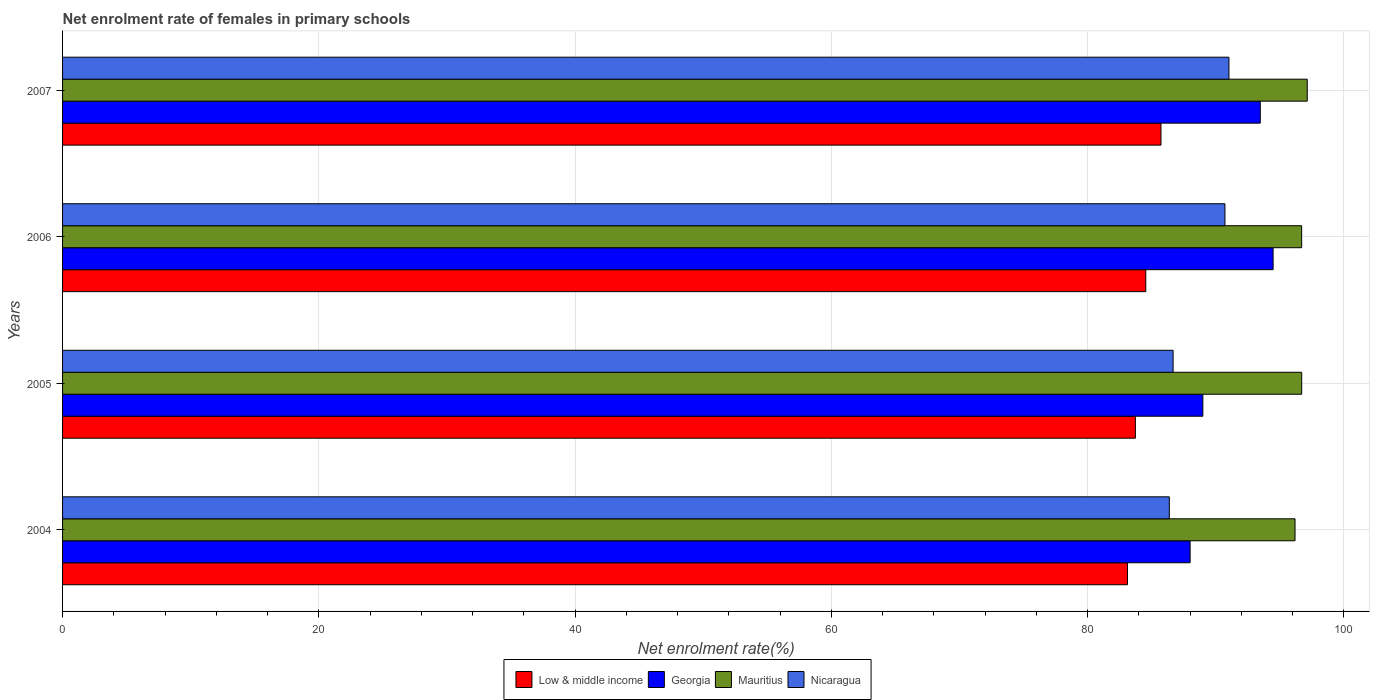Are the number of bars per tick equal to the number of legend labels?
Your answer should be compact. Yes. How many bars are there on the 2nd tick from the bottom?
Provide a short and direct response. 4. What is the label of the 3rd group of bars from the top?
Give a very brief answer. 2005. What is the net enrolment rate of females in primary schools in Georgia in 2005?
Your answer should be very brief. 89. Across all years, what is the maximum net enrolment rate of females in primary schools in Mauritius?
Ensure brevity in your answer.  97.15. Across all years, what is the minimum net enrolment rate of females in primary schools in Low & middle income?
Your answer should be compact. 83.11. In which year was the net enrolment rate of females in primary schools in Low & middle income maximum?
Keep it short and to the point. 2007. In which year was the net enrolment rate of females in primary schools in Nicaragua minimum?
Provide a short and direct response. 2004. What is the total net enrolment rate of females in primary schools in Nicaragua in the graph?
Provide a short and direct response. 354.81. What is the difference between the net enrolment rate of females in primary schools in Mauritius in 2004 and that in 2006?
Your answer should be compact. -0.52. What is the difference between the net enrolment rate of females in primary schools in Georgia in 2004 and the net enrolment rate of females in primary schools in Mauritius in 2006?
Keep it short and to the point. -8.71. What is the average net enrolment rate of females in primary schools in Low & middle income per year?
Give a very brief answer. 84.28. In the year 2007, what is the difference between the net enrolment rate of females in primary schools in Georgia and net enrolment rate of females in primary schools in Nicaragua?
Offer a very short reply. 2.45. What is the ratio of the net enrolment rate of females in primary schools in Georgia in 2006 to that in 2007?
Keep it short and to the point. 1.01. Is the net enrolment rate of females in primary schools in Low & middle income in 2004 less than that in 2005?
Give a very brief answer. Yes. Is the difference between the net enrolment rate of females in primary schools in Georgia in 2006 and 2007 greater than the difference between the net enrolment rate of females in primary schools in Nicaragua in 2006 and 2007?
Your answer should be very brief. Yes. What is the difference between the highest and the second highest net enrolment rate of females in primary schools in Low & middle income?
Ensure brevity in your answer.  1.19. What is the difference between the highest and the lowest net enrolment rate of females in primary schools in Mauritius?
Ensure brevity in your answer.  0.95. In how many years, is the net enrolment rate of females in primary schools in Low & middle income greater than the average net enrolment rate of females in primary schools in Low & middle income taken over all years?
Make the answer very short. 2. Is the sum of the net enrolment rate of females in primary schools in Nicaragua in 2005 and 2007 greater than the maximum net enrolment rate of females in primary schools in Low & middle income across all years?
Provide a succinct answer. Yes. What does the 2nd bar from the top in 2006 represents?
Keep it short and to the point. Mauritius. What does the 1st bar from the bottom in 2007 represents?
Provide a succinct answer. Low & middle income. Are all the bars in the graph horizontal?
Your answer should be compact. Yes. How many years are there in the graph?
Your answer should be compact. 4. Does the graph contain any zero values?
Give a very brief answer. No. Does the graph contain grids?
Provide a short and direct response. Yes. How are the legend labels stacked?
Keep it short and to the point. Horizontal. What is the title of the graph?
Keep it short and to the point. Net enrolment rate of females in primary schools. What is the label or title of the X-axis?
Give a very brief answer. Net enrolment rate(%). What is the Net enrolment rate(%) of Low & middle income in 2004?
Keep it short and to the point. 83.11. What is the Net enrolment rate(%) in Georgia in 2004?
Give a very brief answer. 88. What is the Net enrolment rate(%) in Mauritius in 2004?
Your answer should be very brief. 96.19. What is the Net enrolment rate(%) in Nicaragua in 2004?
Give a very brief answer. 86.38. What is the Net enrolment rate(%) of Low & middle income in 2005?
Your answer should be very brief. 83.73. What is the Net enrolment rate(%) in Georgia in 2005?
Your answer should be very brief. 89. What is the Net enrolment rate(%) of Mauritius in 2005?
Keep it short and to the point. 96.71. What is the Net enrolment rate(%) of Nicaragua in 2005?
Keep it short and to the point. 86.67. What is the Net enrolment rate(%) of Low & middle income in 2006?
Provide a succinct answer. 84.54. What is the Net enrolment rate(%) of Georgia in 2006?
Provide a succinct answer. 94.48. What is the Net enrolment rate(%) of Mauritius in 2006?
Ensure brevity in your answer.  96.71. What is the Net enrolment rate(%) in Nicaragua in 2006?
Offer a terse response. 90.72. What is the Net enrolment rate(%) of Low & middle income in 2007?
Offer a terse response. 85.73. What is the Net enrolment rate(%) in Georgia in 2007?
Offer a terse response. 93.48. What is the Net enrolment rate(%) in Mauritius in 2007?
Give a very brief answer. 97.15. What is the Net enrolment rate(%) of Nicaragua in 2007?
Provide a short and direct response. 91.03. Across all years, what is the maximum Net enrolment rate(%) in Low & middle income?
Keep it short and to the point. 85.73. Across all years, what is the maximum Net enrolment rate(%) in Georgia?
Give a very brief answer. 94.48. Across all years, what is the maximum Net enrolment rate(%) in Mauritius?
Your answer should be compact. 97.15. Across all years, what is the maximum Net enrolment rate(%) in Nicaragua?
Your response must be concise. 91.03. Across all years, what is the minimum Net enrolment rate(%) of Low & middle income?
Ensure brevity in your answer.  83.11. Across all years, what is the minimum Net enrolment rate(%) of Georgia?
Ensure brevity in your answer.  88. Across all years, what is the minimum Net enrolment rate(%) of Mauritius?
Provide a succinct answer. 96.19. Across all years, what is the minimum Net enrolment rate(%) in Nicaragua?
Your answer should be compact. 86.38. What is the total Net enrolment rate(%) in Low & middle income in the graph?
Your answer should be very brief. 337.12. What is the total Net enrolment rate(%) in Georgia in the graph?
Keep it short and to the point. 364.96. What is the total Net enrolment rate(%) of Mauritius in the graph?
Offer a very short reply. 386.76. What is the total Net enrolment rate(%) of Nicaragua in the graph?
Ensure brevity in your answer.  354.81. What is the difference between the Net enrolment rate(%) in Low & middle income in 2004 and that in 2005?
Provide a succinct answer. -0.62. What is the difference between the Net enrolment rate(%) in Georgia in 2004 and that in 2005?
Make the answer very short. -0.99. What is the difference between the Net enrolment rate(%) of Mauritius in 2004 and that in 2005?
Offer a terse response. -0.52. What is the difference between the Net enrolment rate(%) of Nicaragua in 2004 and that in 2005?
Offer a very short reply. -0.3. What is the difference between the Net enrolment rate(%) in Low & middle income in 2004 and that in 2006?
Your answer should be compact. -1.43. What is the difference between the Net enrolment rate(%) of Georgia in 2004 and that in 2006?
Give a very brief answer. -6.48. What is the difference between the Net enrolment rate(%) of Mauritius in 2004 and that in 2006?
Your response must be concise. -0.52. What is the difference between the Net enrolment rate(%) in Nicaragua in 2004 and that in 2006?
Your answer should be very brief. -4.34. What is the difference between the Net enrolment rate(%) of Low & middle income in 2004 and that in 2007?
Offer a very short reply. -2.61. What is the difference between the Net enrolment rate(%) in Georgia in 2004 and that in 2007?
Provide a short and direct response. -5.48. What is the difference between the Net enrolment rate(%) in Mauritius in 2004 and that in 2007?
Keep it short and to the point. -0.95. What is the difference between the Net enrolment rate(%) in Nicaragua in 2004 and that in 2007?
Provide a short and direct response. -4.66. What is the difference between the Net enrolment rate(%) in Low & middle income in 2005 and that in 2006?
Your response must be concise. -0.81. What is the difference between the Net enrolment rate(%) in Georgia in 2005 and that in 2006?
Provide a short and direct response. -5.48. What is the difference between the Net enrolment rate(%) in Mauritius in 2005 and that in 2006?
Your response must be concise. 0. What is the difference between the Net enrolment rate(%) of Nicaragua in 2005 and that in 2006?
Provide a succinct answer. -4.05. What is the difference between the Net enrolment rate(%) of Low & middle income in 2005 and that in 2007?
Offer a very short reply. -2. What is the difference between the Net enrolment rate(%) in Georgia in 2005 and that in 2007?
Provide a short and direct response. -4.48. What is the difference between the Net enrolment rate(%) in Mauritius in 2005 and that in 2007?
Your answer should be very brief. -0.43. What is the difference between the Net enrolment rate(%) of Nicaragua in 2005 and that in 2007?
Your answer should be very brief. -4.36. What is the difference between the Net enrolment rate(%) of Low & middle income in 2006 and that in 2007?
Your answer should be very brief. -1.19. What is the difference between the Net enrolment rate(%) in Georgia in 2006 and that in 2007?
Make the answer very short. 1. What is the difference between the Net enrolment rate(%) of Mauritius in 2006 and that in 2007?
Ensure brevity in your answer.  -0.44. What is the difference between the Net enrolment rate(%) of Nicaragua in 2006 and that in 2007?
Keep it short and to the point. -0.31. What is the difference between the Net enrolment rate(%) in Low & middle income in 2004 and the Net enrolment rate(%) in Georgia in 2005?
Keep it short and to the point. -5.88. What is the difference between the Net enrolment rate(%) of Low & middle income in 2004 and the Net enrolment rate(%) of Mauritius in 2005?
Keep it short and to the point. -13.6. What is the difference between the Net enrolment rate(%) of Low & middle income in 2004 and the Net enrolment rate(%) of Nicaragua in 2005?
Ensure brevity in your answer.  -3.56. What is the difference between the Net enrolment rate(%) of Georgia in 2004 and the Net enrolment rate(%) of Mauritius in 2005?
Your answer should be compact. -8.71. What is the difference between the Net enrolment rate(%) in Georgia in 2004 and the Net enrolment rate(%) in Nicaragua in 2005?
Your answer should be very brief. 1.33. What is the difference between the Net enrolment rate(%) in Mauritius in 2004 and the Net enrolment rate(%) in Nicaragua in 2005?
Ensure brevity in your answer.  9.52. What is the difference between the Net enrolment rate(%) in Low & middle income in 2004 and the Net enrolment rate(%) in Georgia in 2006?
Offer a terse response. -11.37. What is the difference between the Net enrolment rate(%) in Low & middle income in 2004 and the Net enrolment rate(%) in Mauritius in 2006?
Offer a terse response. -13.59. What is the difference between the Net enrolment rate(%) in Low & middle income in 2004 and the Net enrolment rate(%) in Nicaragua in 2006?
Your response must be concise. -7.61. What is the difference between the Net enrolment rate(%) in Georgia in 2004 and the Net enrolment rate(%) in Mauritius in 2006?
Give a very brief answer. -8.71. What is the difference between the Net enrolment rate(%) in Georgia in 2004 and the Net enrolment rate(%) in Nicaragua in 2006?
Keep it short and to the point. -2.72. What is the difference between the Net enrolment rate(%) in Mauritius in 2004 and the Net enrolment rate(%) in Nicaragua in 2006?
Provide a succinct answer. 5.47. What is the difference between the Net enrolment rate(%) in Low & middle income in 2004 and the Net enrolment rate(%) in Georgia in 2007?
Offer a very short reply. -10.37. What is the difference between the Net enrolment rate(%) of Low & middle income in 2004 and the Net enrolment rate(%) of Mauritius in 2007?
Ensure brevity in your answer.  -14.03. What is the difference between the Net enrolment rate(%) of Low & middle income in 2004 and the Net enrolment rate(%) of Nicaragua in 2007?
Provide a short and direct response. -7.92. What is the difference between the Net enrolment rate(%) in Georgia in 2004 and the Net enrolment rate(%) in Mauritius in 2007?
Ensure brevity in your answer.  -9.14. What is the difference between the Net enrolment rate(%) in Georgia in 2004 and the Net enrolment rate(%) in Nicaragua in 2007?
Make the answer very short. -3.03. What is the difference between the Net enrolment rate(%) of Mauritius in 2004 and the Net enrolment rate(%) of Nicaragua in 2007?
Offer a terse response. 5.16. What is the difference between the Net enrolment rate(%) in Low & middle income in 2005 and the Net enrolment rate(%) in Georgia in 2006?
Provide a short and direct response. -10.75. What is the difference between the Net enrolment rate(%) of Low & middle income in 2005 and the Net enrolment rate(%) of Mauritius in 2006?
Make the answer very short. -12.98. What is the difference between the Net enrolment rate(%) in Low & middle income in 2005 and the Net enrolment rate(%) in Nicaragua in 2006?
Provide a succinct answer. -6.99. What is the difference between the Net enrolment rate(%) of Georgia in 2005 and the Net enrolment rate(%) of Mauritius in 2006?
Keep it short and to the point. -7.71. What is the difference between the Net enrolment rate(%) of Georgia in 2005 and the Net enrolment rate(%) of Nicaragua in 2006?
Your answer should be compact. -1.72. What is the difference between the Net enrolment rate(%) of Mauritius in 2005 and the Net enrolment rate(%) of Nicaragua in 2006?
Provide a succinct answer. 5.99. What is the difference between the Net enrolment rate(%) in Low & middle income in 2005 and the Net enrolment rate(%) in Georgia in 2007?
Offer a very short reply. -9.75. What is the difference between the Net enrolment rate(%) of Low & middle income in 2005 and the Net enrolment rate(%) of Mauritius in 2007?
Your answer should be very brief. -13.41. What is the difference between the Net enrolment rate(%) of Low & middle income in 2005 and the Net enrolment rate(%) of Nicaragua in 2007?
Your response must be concise. -7.3. What is the difference between the Net enrolment rate(%) of Georgia in 2005 and the Net enrolment rate(%) of Mauritius in 2007?
Provide a succinct answer. -8.15. What is the difference between the Net enrolment rate(%) in Georgia in 2005 and the Net enrolment rate(%) in Nicaragua in 2007?
Make the answer very short. -2.04. What is the difference between the Net enrolment rate(%) of Mauritius in 2005 and the Net enrolment rate(%) of Nicaragua in 2007?
Your response must be concise. 5.68. What is the difference between the Net enrolment rate(%) of Low & middle income in 2006 and the Net enrolment rate(%) of Georgia in 2007?
Give a very brief answer. -8.94. What is the difference between the Net enrolment rate(%) in Low & middle income in 2006 and the Net enrolment rate(%) in Mauritius in 2007?
Keep it short and to the point. -12.6. What is the difference between the Net enrolment rate(%) of Low & middle income in 2006 and the Net enrolment rate(%) of Nicaragua in 2007?
Offer a very short reply. -6.49. What is the difference between the Net enrolment rate(%) in Georgia in 2006 and the Net enrolment rate(%) in Mauritius in 2007?
Your response must be concise. -2.67. What is the difference between the Net enrolment rate(%) of Georgia in 2006 and the Net enrolment rate(%) of Nicaragua in 2007?
Your answer should be very brief. 3.45. What is the difference between the Net enrolment rate(%) in Mauritius in 2006 and the Net enrolment rate(%) in Nicaragua in 2007?
Provide a succinct answer. 5.67. What is the average Net enrolment rate(%) in Low & middle income per year?
Ensure brevity in your answer.  84.28. What is the average Net enrolment rate(%) in Georgia per year?
Provide a short and direct response. 91.24. What is the average Net enrolment rate(%) of Mauritius per year?
Offer a terse response. 96.69. What is the average Net enrolment rate(%) in Nicaragua per year?
Keep it short and to the point. 88.7. In the year 2004, what is the difference between the Net enrolment rate(%) in Low & middle income and Net enrolment rate(%) in Georgia?
Keep it short and to the point. -4.89. In the year 2004, what is the difference between the Net enrolment rate(%) of Low & middle income and Net enrolment rate(%) of Mauritius?
Offer a very short reply. -13.08. In the year 2004, what is the difference between the Net enrolment rate(%) in Low & middle income and Net enrolment rate(%) in Nicaragua?
Your response must be concise. -3.27. In the year 2004, what is the difference between the Net enrolment rate(%) in Georgia and Net enrolment rate(%) in Mauritius?
Your response must be concise. -8.19. In the year 2004, what is the difference between the Net enrolment rate(%) of Georgia and Net enrolment rate(%) of Nicaragua?
Keep it short and to the point. 1.62. In the year 2004, what is the difference between the Net enrolment rate(%) in Mauritius and Net enrolment rate(%) in Nicaragua?
Give a very brief answer. 9.81. In the year 2005, what is the difference between the Net enrolment rate(%) of Low & middle income and Net enrolment rate(%) of Georgia?
Your answer should be very brief. -5.26. In the year 2005, what is the difference between the Net enrolment rate(%) of Low & middle income and Net enrolment rate(%) of Mauritius?
Your response must be concise. -12.98. In the year 2005, what is the difference between the Net enrolment rate(%) in Low & middle income and Net enrolment rate(%) in Nicaragua?
Keep it short and to the point. -2.94. In the year 2005, what is the difference between the Net enrolment rate(%) in Georgia and Net enrolment rate(%) in Mauritius?
Keep it short and to the point. -7.71. In the year 2005, what is the difference between the Net enrolment rate(%) in Georgia and Net enrolment rate(%) in Nicaragua?
Make the answer very short. 2.32. In the year 2005, what is the difference between the Net enrolment rate(%) of Mauritius and Net enrolment rate(%) of Nicaragua?
Make the answer very short. 10.04. In the year 2006, what is the difference between the Net enrolment rate(%) in Low & middle income and Net enrolment rate(%) in Georgia?
Offer a terse response. -9.94. In the year 2006, what is the difference between the Net enrolment rate(%) in Low & middle income and Net enrolment rate(%) in Mauritius?
Your response must be concise. -12.17. In the year 2006, what is the difference between the Net enrolment rate(%) in Low & middle income and Net enrolment rate(%) in Nicaragua?
Offer a terse response. -6.18. In the year 2006, what is the difference between the Net enrolment rate(%) in Georgia and Net enrolment rate(%) in Mauritius?
Your answer should be very brief. -2.23. In the year 2006, what is the difference between the Net enrolment rate(%) of Georgia and Net enrolment rate(%) of Nicaragua?
Offer a very short reply. 3.76. In the year 2006, what is the difference between the Net enrolment rate(%) of Mauritius and Net enrolment rate(%) of Nicaragua?
Offer a terse response. 5.99. In the year 2007, what is the difference between the Net enrolment rate(%) of Low & middle income and Net enrolment rate(%) of Georgia?
Ensure brevity in your answer.  -7.75. In the year 2007, what is the difference between the Net enrolment rate(%) in Low & middle income and Net enrolment rate(%) in Mauritius?
Your answer should be compact. -11.42. In the year 2007, what is the difference between the Net enrolment rate(%) in Low & middle income and Net enrolment rate(%) in Nicaragua?
Offer a very short reply. -5.31. In the year 2007, what is the difference between the Net enrolment rate(%) of Georgia and Net enrolment rate(%) of Mauritius?
Keep it short and to the point. -3.67. In the year 2007, what is the difference between the Net enrolment rate(%) in Georgia and Net enrolment rate(%) in Nicaragua?
Keep it short and to the point. 2.45. In the year 2007, what is the difference between the Net enrolment rate(%) in Mauritius and Net enrolment rate(%) in Nicaragua?
Make the answer very short. 6.11. What is the ratio of the Net enrolment rate(%) of Low & middle income in 2004 to that in 2005?
Your response must be concise. 0.99. What is the ratio of the Net enrolment rate(%) in Georgia in 2004 to that in 2005?
Ensure brevity in your answer.  0.99. What is the ratio of the Net enrolment rate(%) in Mauritius in 2004 to that in 2005?
Provide a succinct answer. 0.99. What is the ratio of the Net enrolment rate(%) in Low & middle income in 2004 to that in 2006?
Your answer should be very brief. 0.98. What is the ratio of the Net enrolment rate(%) in Georgia in 2004 to that in 2006?
Offer a very short reply. 0.93. What is the ratio of the Net enrolment rate(%) of Mauritius in 2004 to that in 2006?
Provide a short and direct response. 0.99. What is the ratio of the Net enrolment rate(%) in Nicaragua in 2004 to that in 2006?
Provide a succinct answer. 0.95. What is the ratio of the Net enrolment rate(%) in Low & middle income in 2004 to that in 2007?
Your response must be concise. 0.97. What is the ratio of the Net enrolment rate(%) in Georgia in 2004 to that in 2007?
Your response must be concise. 0.94. What is the ratio of the Net enrolment rate(%) in Mauritius in 2004 to that in 2007?
Give a very brief answer. 0.99. What is the ratio of the Net enrolment rate(%) of Nicaragua in 2004 to that in 2007?
Ensure brevity in your answer.  0.95. What is the ratio of the Net enrolment rate(%) in Georgia in 2005 to that in 2006?
Ensure brevity in your answer.  0.94. What is the ratio of the Net enrolment rate(%) in Nicaragua in 2005 to that in 2006?
Your answer should be very brief. 0.96. What is the ratio of the Net enrolment rate(%) of Low & middle income in 2005 to that in 2007?
Offer a terse response. 0.98. What is the ratio of the Net enrolment rate(%) in Georgia in 2005 to that in 2007?
Give a very brief answer. 0.95. What is the ratio of the Net enrolment rate(%) of Nicaragua in 2005 to that in 2007?
Your response must be concise. 0.95. What is the ratio of the Net enrolment rate(%) of Low & middle income in 2006 to that in 2007?
Your response must be concise. 0.99. What is the ratio of the Net enrolment rate(%) in Georgia in 2006 to that in 2007?
Your answer should be very brief. 1.01. What is the ratio of the Net enrolment rate(%) of Mauritius in 2006 to that in 2007?
Your answer should be compact. 1. What is the difference between the highest and the second highest Net enrolment rate(%) of Low & middle income?
Provide a succinct answer. 1.19. What is the difference between the highest and the second highest Net enrolment rate(%) of Mauritius?
Keep it short and to the point. 0.43. What is the difference between the highest and the second highest Net enrolment rate(%) in Nicaragua?
Keep it short and to the point. 0.31. What is the difference between the highest and the lowest Net enrolment rate(%) of Low & middle income?
Make the answer very short. 2.61. What is the difference between the highest and the lowest Net enrolment rate(%) in Georgia?
Offer a terse response. 6.48. What is the difference between the highest and the lowest Net enrolment rate(%) in Mauritius?
Ensure brevity in your answer.  0.95. What is the difference between the highest and the lowest Net enrolment rate(%) of Nicaragua?
Ensure brevity in your answer.  4.66. 